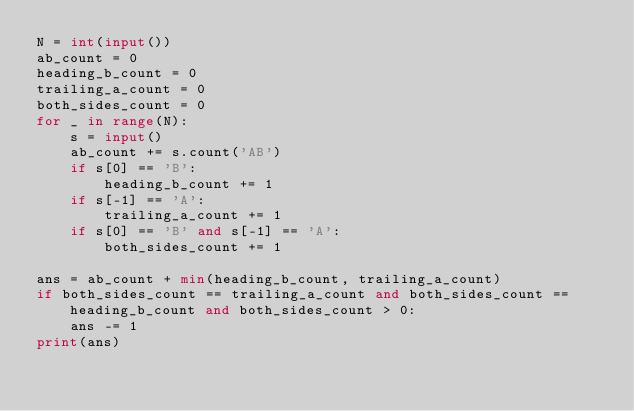<code> <loc_0><loc_0><loc_500><loc_500><_Python_>N = int(input())
ab_count = 0
heading_b_count = 0
trailing_a_count = 0
both_sides_count = 0
for _ in range(N):
    s = input()
    ab_count += s.count('AB')
    if s[0] == 'B':
        heading_b_count += 1
    if s[-1] == 'A':
        trailing_a_count += 1
    if s[0] == 'B' and s[-1] == 'A':
        both_sides_count += 1

ans = ab_count + min(heading_b_count, trailing_a_count)
if both_sides_count == trailing_a_count and both_sides_count == heading_b_count and both_sides_count > 0:
    ans -= 1
print(ans)
</code> 